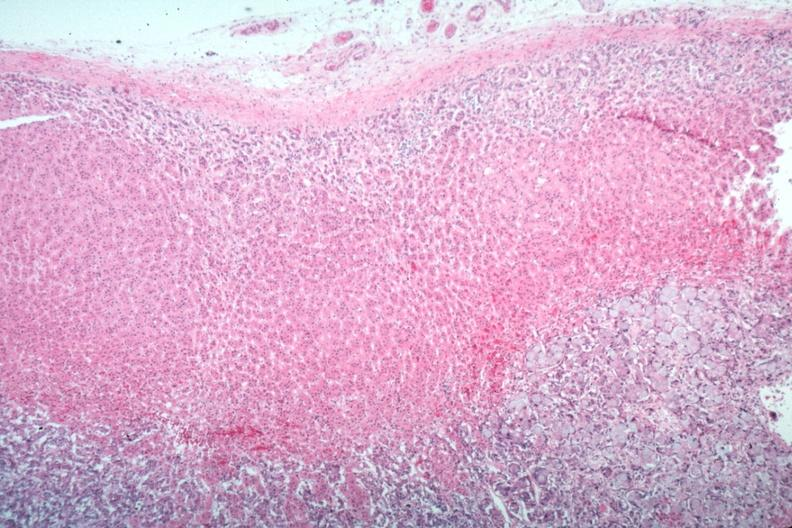s hematoma present?
Answer the question using a single word or phrase. No 